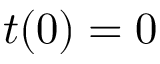Convert formula to latex. <formula><loc_0><loc_0><loc_500><loc_500>t ( 0 ) = 0</formula> 